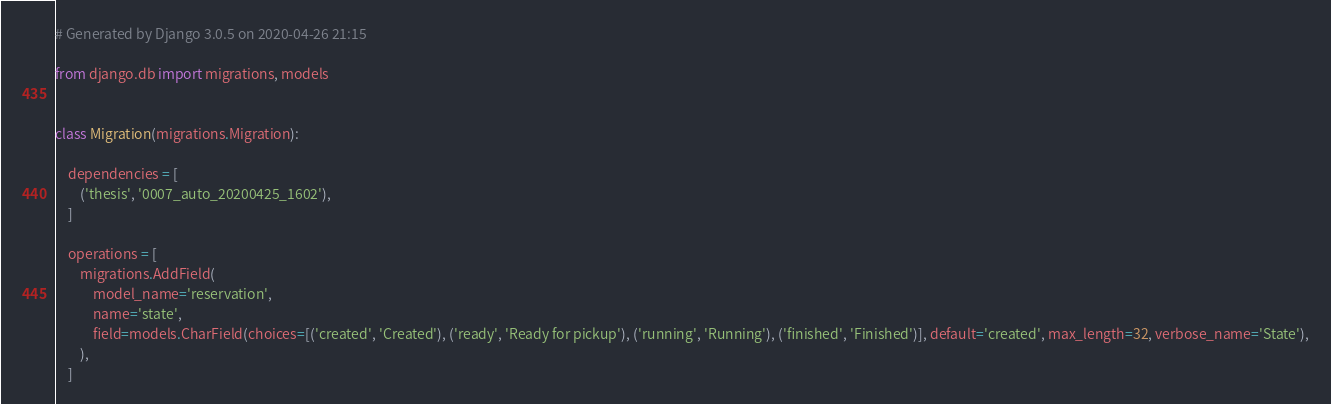<code> <loc_0><loc_0><loc_500><loc_500><_Python_># Generated by Django 3.0.5 on 2020-04-26 21:15

from django.db import migrations, models


class Migration(migrations.Migration):

    dependencies = [
        ('thesis', '0007_auto_20200425_1602'),
    ]

    operations = [
        migrations.AddField(
            model_name='reservation',
            name='state',
            field=models.CharField(choices=[('created', 'Created'), ('ready', 'Ready for pickup'), ('running', 'Running'), ('finished', 'Finished')], default='created', max_length=32, verbose_name='State'),
        ),
    ]
</code> 